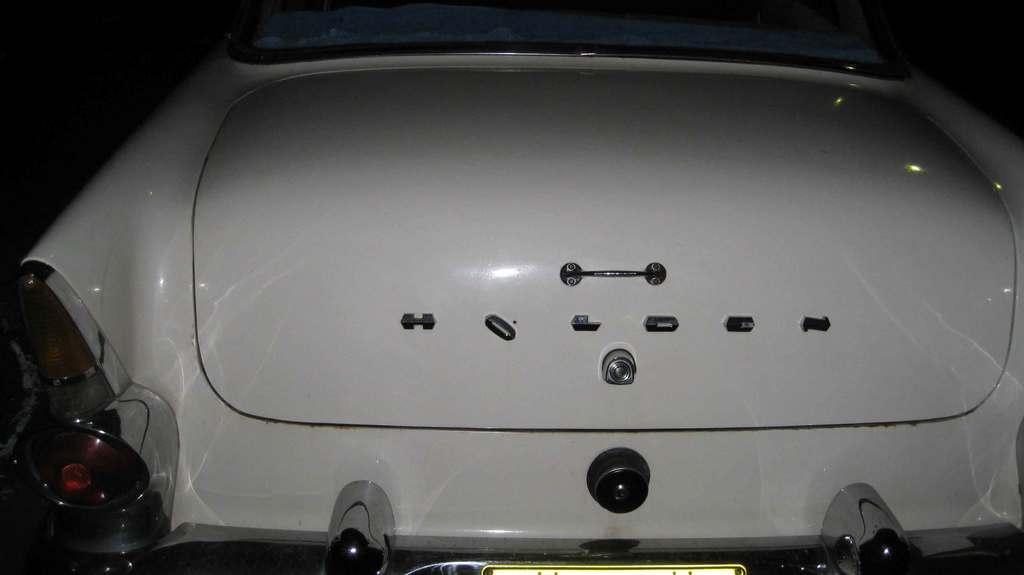How would you summarize this image in a sentence or two? In this image there is a vehicle having a handle attached to it. Bottom of the image a number plate is attached to the vehicle having few lights. 